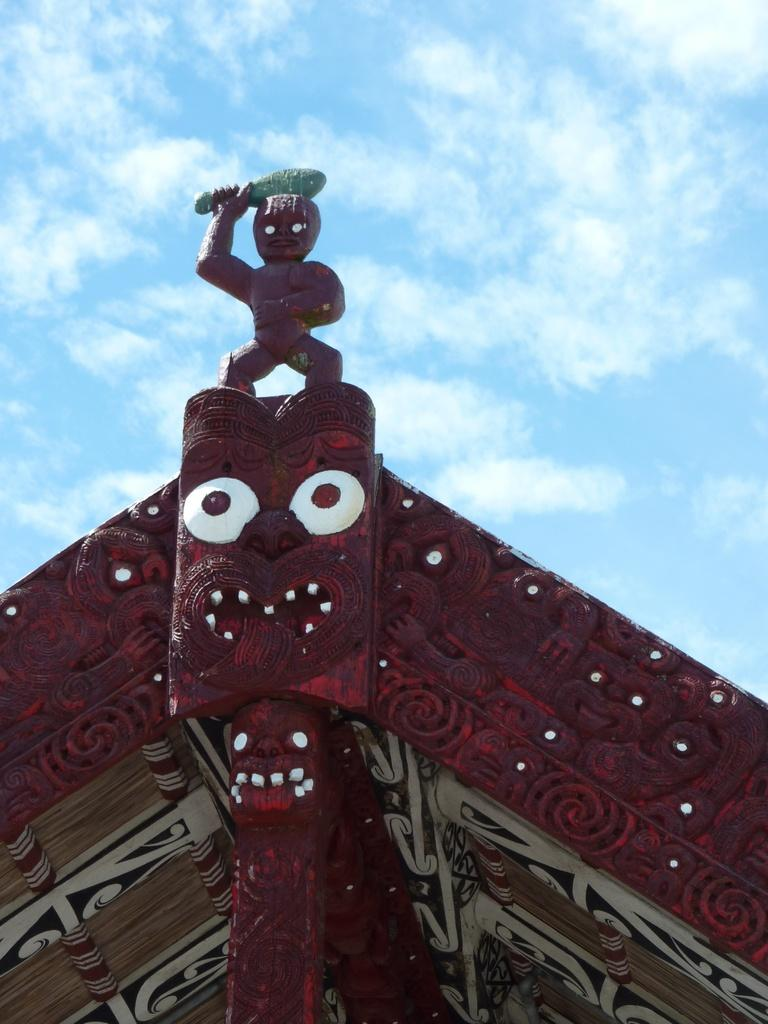What is located on the top of the building in the image? There is a statue on the top of the building in the image. What color is the building? The building is in maroon color. What can be seen in the sky in the background of the image? There are clouds in the sky in the background of the image. What type of yam is being harvested in the image? There is no yam present in the image; it features a statue on top of a maroon-colored building with clouds in the sky. What time of day is it in the image? The time of day is not mentioned in the image, but it can be inferred that it is daytime due to the visibility of the statue and clouds. 